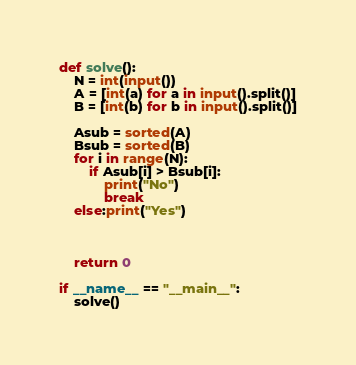Convert code to text. <code><loc_0><loc_0><loc_500><loc_500><_Python_>def solve():
    N = int(input())
    A = [int(a) for a in input().split()]
    B = [int(b) for b in input().split()]

    Asub = sorted(A)
    Bsub = sorted(B)
    for i in range(N):
        if Asub[i] > Bsub[i]:
            print("No")
            break
    else:print("Yes")



    return 0

if __name__ == "__main__":
    solve()</code> 